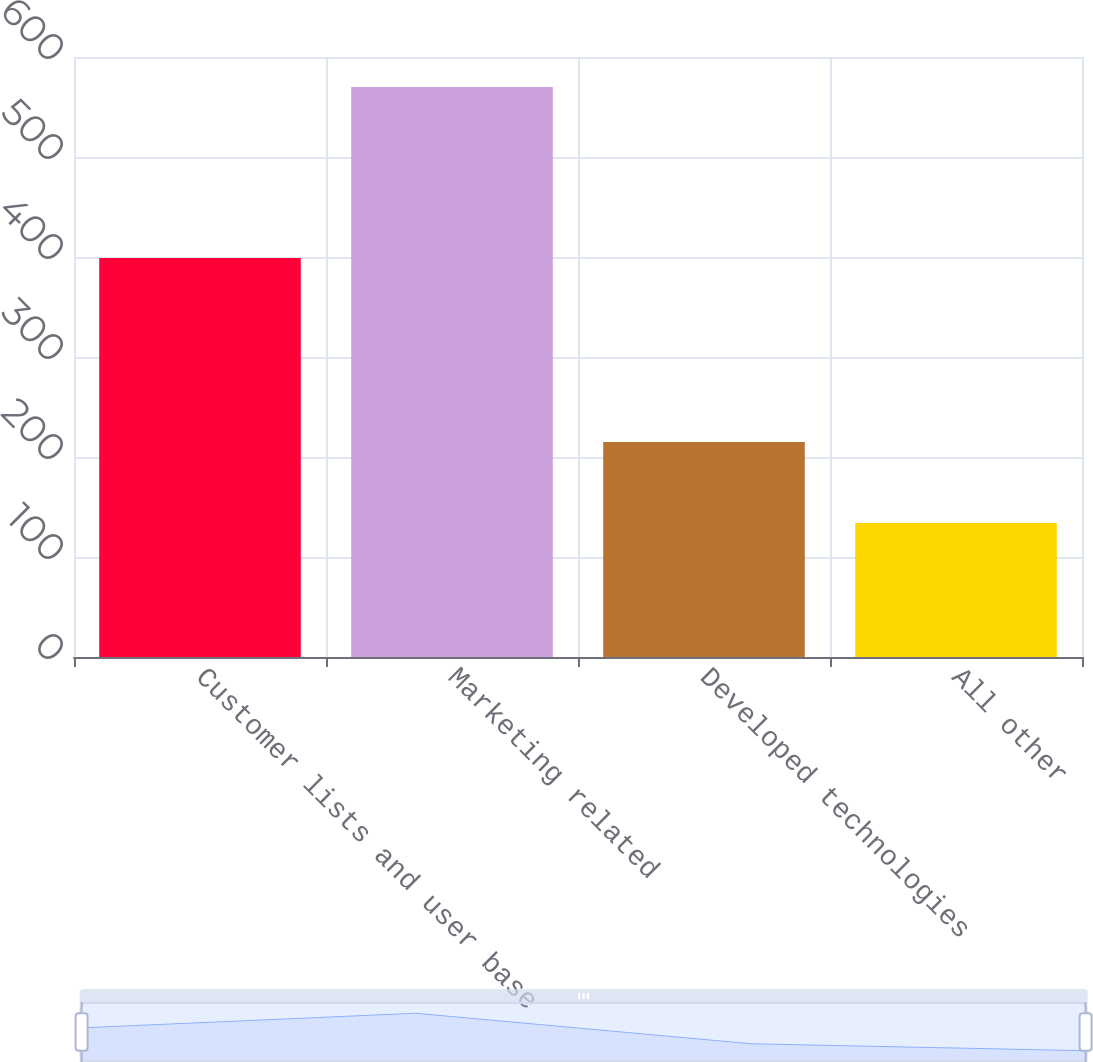Convert chart to OTSL. <chart><loc_0><loc_0><loc_500><loc_500><bar_chart><fcel>Customer lists and user base<fcel>Marketing related<fcel>Developed technologies<fcel>All other<nl><fcel>399<fcel>570<fcel>215<fcel>134<nl></chart> 